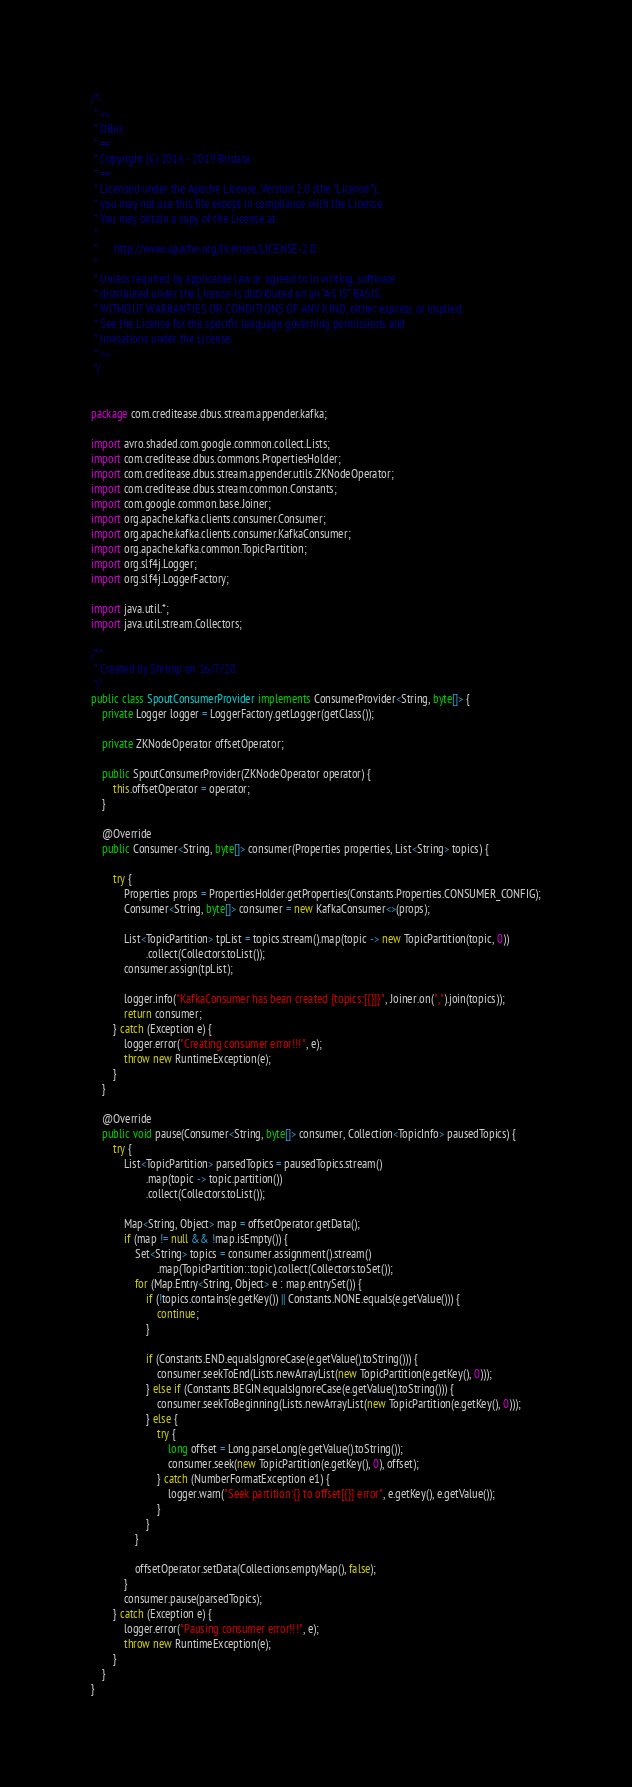<code> <loc_0><loc_0><loc_500><loc_500><_Java_>/*-
 * <<
 * DBus
 * ==
 * Copyright (C) 2016 - 2019 Bridata
 * ==
 * Licensed under the Apache License, Version 2.0 (the "License");
 * you may not use this file except in compliance with the License.
 * You may obtain a copy of the License at
 * 
 *      http://www.apache.org/licenses/LICENSE-2.0
 * 
 * Unless required by applicable law or agreed to in writing, software
 * distributed under the License is distributed on an "AS IS" BASIS,
 * WITHOUT WARRANTIES OR CONDITIONS OF ANY KIND, either express or implied.
 * See the License for the specific language governing permissions and
 * limitations under the License.
 * >>
 */


package com.creditease.dbus.stream.appender.kafka;

import avro.shaded.com.google.common.collect.Lists;
import com.creditease.dbus.commons.PropertiesHolder;
import com.creditease.dbus.stream.appender.utils.ZKNodeOperator;
import com.creditease.dbus.stream.common.Constants;
import com.google.common.base.Joiner;
import org.apache.kafka.clients.consumer.Consumer;
import org.apache.kafka.clients.consumer.KafkaConsumer;
import org.apache.kafka.common.TopicPartition;
import org.slf4j.Logger;
import org.slf4j.LoggerFactory;

import java.util.*;
import java.util.stream.Collectors;

/**
 * Created by Shrimp on 16/7/20.
 */
public class SpoutConsumerProvider implements ConsumerProvider<String, byte[]> {
    private Logger logger = LoggerFactory.getLogger(getClass());

    private ZKNodeOperator offsetOperator;

    public SpoutConsumerProvider(ZKNodeOperator operator) {
        this.offsetOperator = operator;
    }

    @Override
    public Consumer<String, byte[]> consumer(Properties properties, List<String> topics) {

        try {
            Properties props = PropertiesHolder.getProperties(Constants.Properties.CONSUMER_CONFIG);
            Consumer<String, byte[]> consumer = new KafkaConsumer<>(props);

            List<TopicPartition> tpList = topics.stream().map(topic -> new TopicPartition(topic, 0))
                    .collect(Collectors.toList());
            consumer.assign(tpList);

            logger.info("KafkaConsumer has bean created {topics:[{}]}", Joiner.on(",").join(topics));
            return consumer;
        } catch (Exception e) {
            logger.error("Creating consumer error!!!", e);
            throw new RuntimeException(e);
        }
    }

    @Override
    public void pause(Consumer<String, byte[]> consumer, Collection<TopicInfo> pausedTopics) {
        try {
            List<TopicPartition> parsedTopics = pausedTopics.stream()
                    .map(topic -> topic.partition())
                    .collect(Collectors.toList());

            Map<String, Object> map = offsetOperator.getData();
            if (map != null && !map.isEmpty()) {
                Set<String> topics = consumer.assignment().stream()
                        .map(TopicPartition::topic).collect(Collectors.toSet());
                for (Map.Entry<String, Object> e : map.entrySet()) {
                    if (!topics.contains(e.getKey()) || Constants.NONE.equals(e.getValue())) {
                        continue;
                    }

                    if (Constants.END.equalsIgnoreCase(e.getValue().toString())) {
                        consumer.seekToEnd(Lists.newArrayList(new TopicPartition(e.getKey(), 0)));
                    } else if (Constants.BEGIN.equalsIgnoreCase(e.getValue().toString())) {
                        consumer.seekToBeginning(Lists.newArrayList(new TopicPartition(e.getKey(), 0)));
                    } else {
                        try {
                            long offset = Long.parseLong(e.getValue().toString());
                            consumer.seek(new TopicPartition(e.getKey(), 0), offset);
                        } catch (NumberFormatException e1) {
                            logger.warn("Seek partition:{} to offset[{}] error", e.getKey(), e.getValue());
                        }
                    }
                }

                offsetOperator.setData(Collections.emptyMap(), false);
            }
            consumer.pause(parsedTopics);
        } catch (Exception e) {
            logger.error("Pausing consumer error!!!", e);
            throw new RuntimeException(e);
        }
    }
}
</code> 